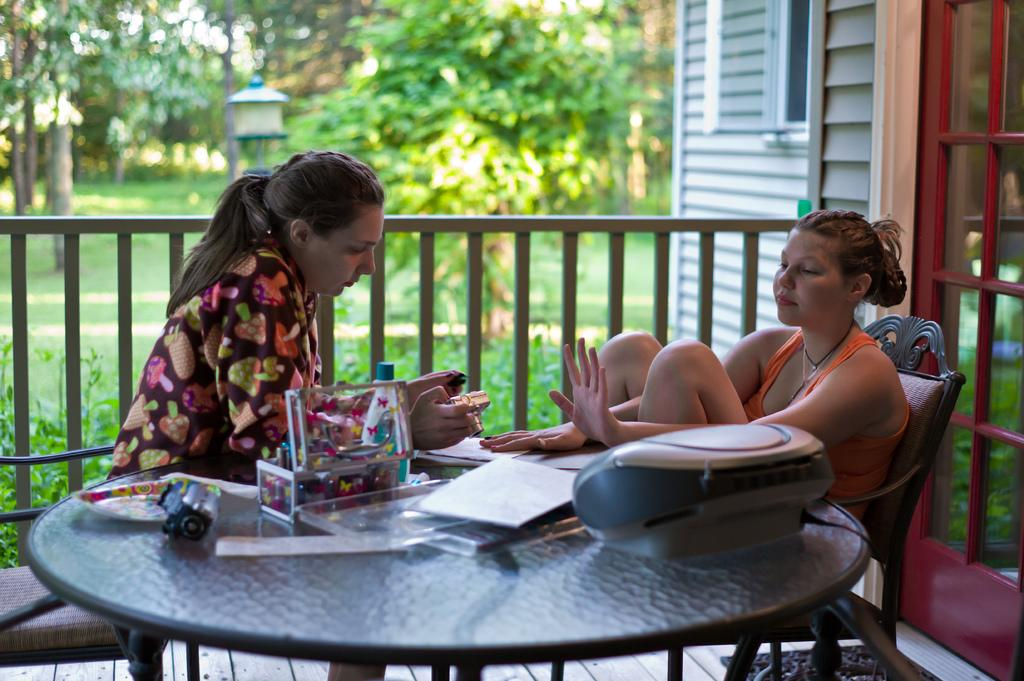How many women are in the image? There are two women in the image. What are the women doing in the image? The women are sitting on chairs. What is the arrangement of the chairs in the image? The chairs are around a table. What items can be seen on the table? There are papers, a bottle, a box, and a camera on the table. What is visible in the background of the image? There are trees and a house in the background of the image. What type of berry is being used to sweeten the sugar in the image? There is no berry or sugar present in the image. What type of needle is being used to take a picture with the camera in the image? There is no needle present in the image, and the camera does not require a needle to take a picture. 